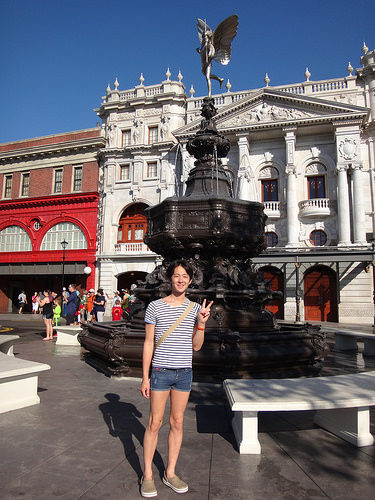<image>
Is the guy behind the bench? No. The guy is not behind the bench. From this viewpoint, the guy appears to be positioned elsewhere in the scene. Is the tourists to the left of the shaded bench? Yes. From this viewpoint, the tourists is positioned to the left side relative to the shaded bench. 